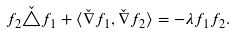Convert formula to latex. <formula><loc_0><loc_0><loc_500><loc_500>f _ { 2 } \check { \triangle } f _ { 1 } + \langle \check { \nabla } f _ { 1 } , \check { \nabla } f _ { 2 } \rangle = - \lambda f _ { 1 } f _ { 2 } .</formula> 